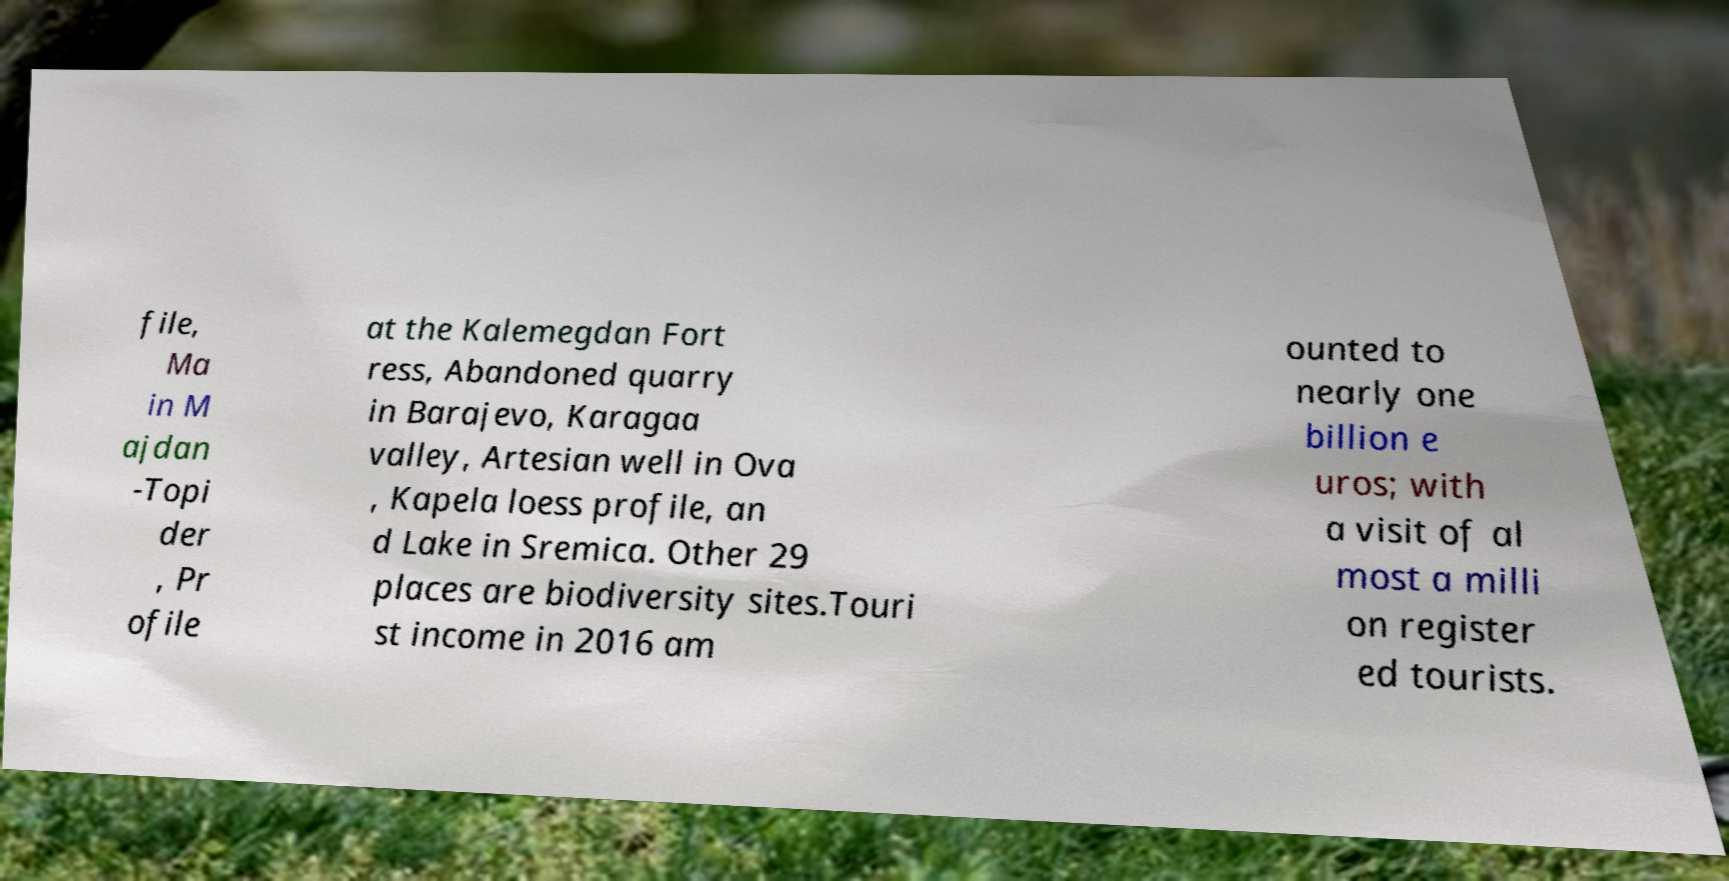Please identify and transcribe the text found in this image. file, Ma in M ajdan -Topi der , Pr ofile at the Kalemegdan Fort ress, Abandoned quarry in Barajevo, Karagaa valley, Artesian well in Ova , Kapela loess profile, an d Lake in Sremica. Other 29 places are biodiversity sites.Touri st income in 2016 am ounted to nearly one billion e uros; with a visit of al most a milli on register ed tourists. 